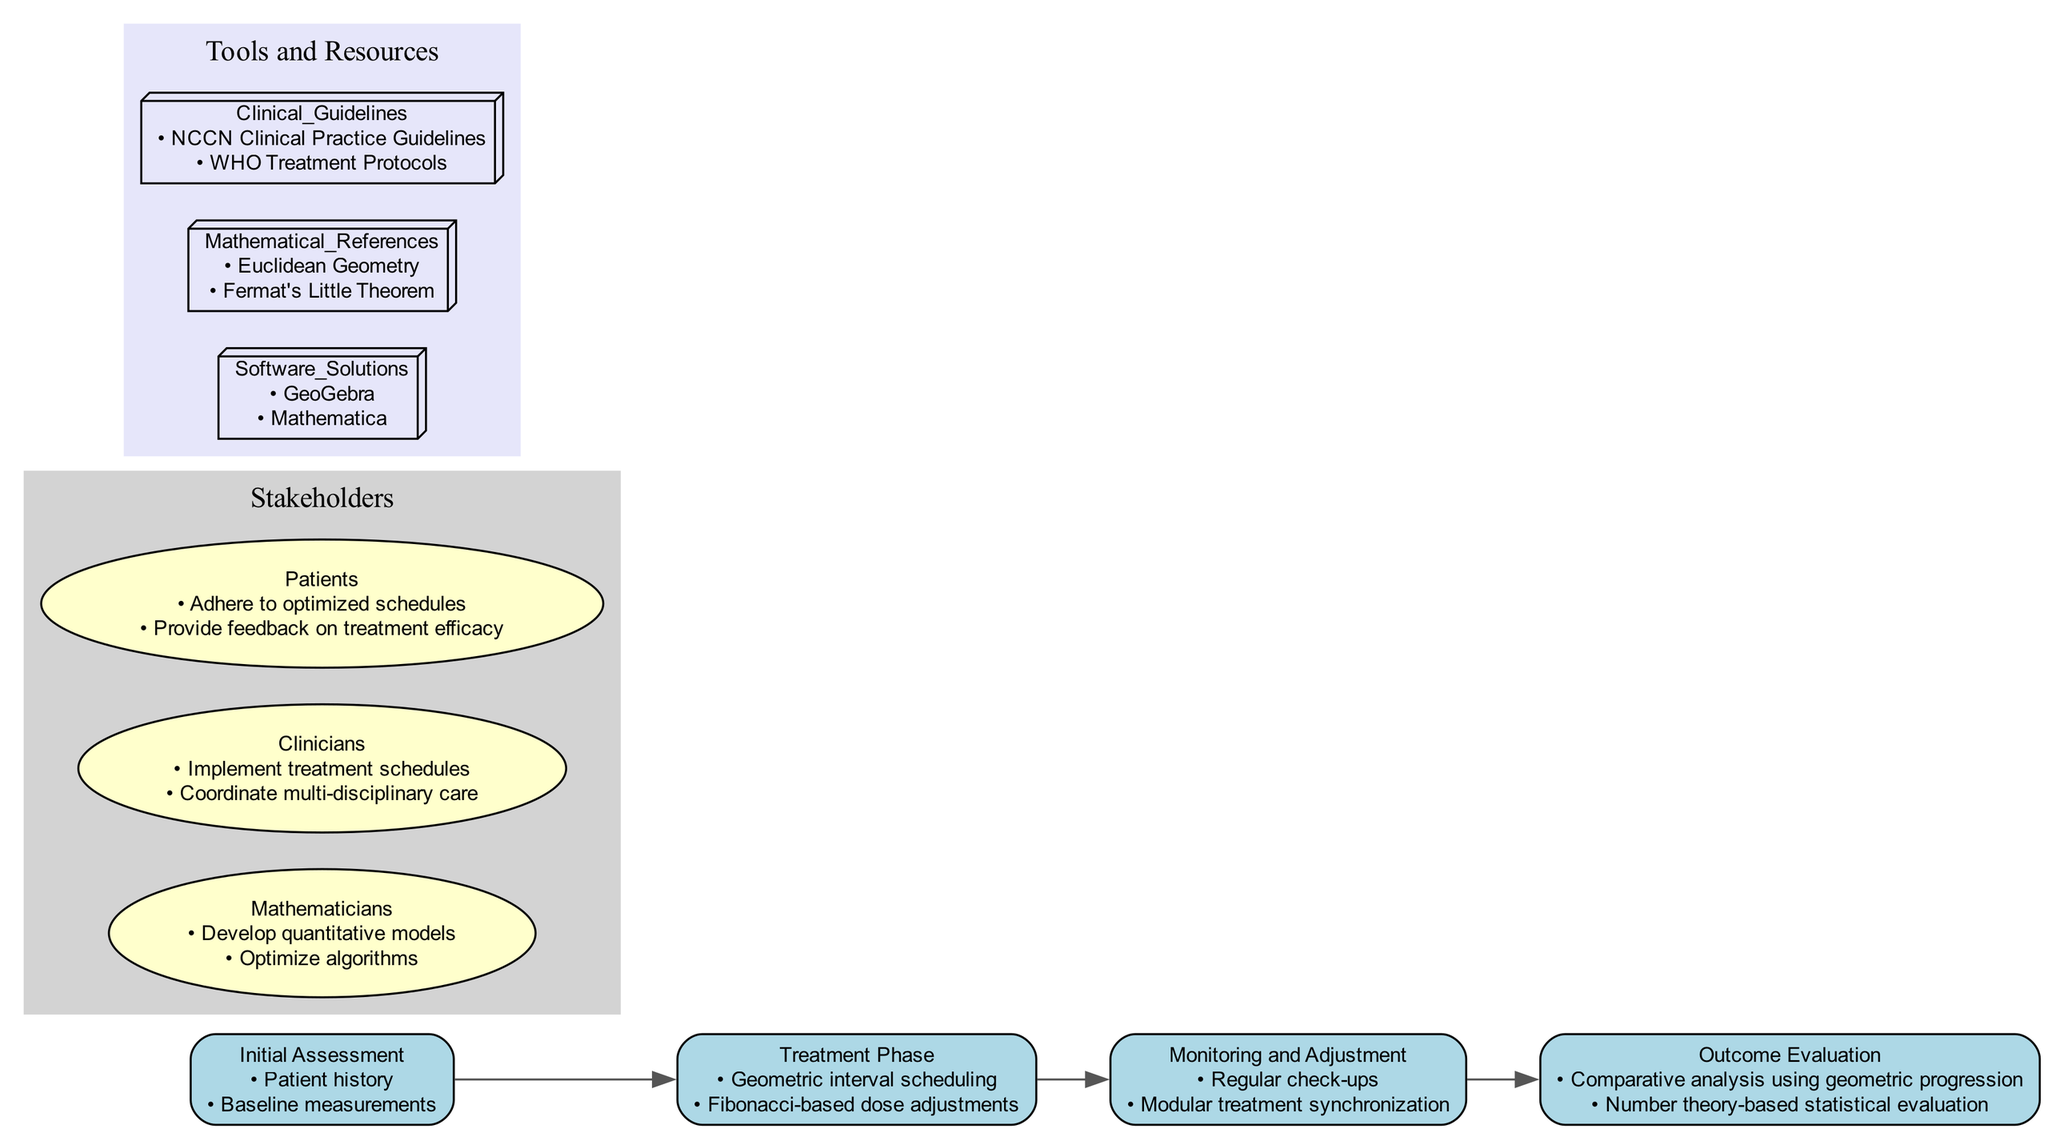What are the geometric shapes mentioned in the diagram? The diagram lists three geometric shapes under the "Geometry Principles" section: Ellipses, Parabolas, and Tessellations. These shapes are used in the context of optimizing treatment schedules.
Answer: Ellipses, Parabolas, Tessellations How many steps are in the Clinical Pathway? The Clinical Pathway consists of four distinct steps: Initial Assessment, Treatment Phase, Monitoring and Adjustment, and Outcome Evaluation. These steps represent the progression of a patient's treatment.
Answer: 4 Which mathematical reference is included in the Tools and Resources section? The Tools and Resources section lists two mathematical references, one of which is Euclidean Geometry. This reference pertains to the geometric aspects of the treatment optimization.
Answer: Euclidean Geometry What roles do clinicians play according to the diagram? Clinicians have two main roles listed in the Stakeholders section: Implement treatment schedules and Coordinate multi-disciplinary care. These roles emphasize their active participation in patient management.
Answer: Implement treatment schedules, Coordinate multi-disciplinary care What method is suggested for dose adjustments in the Treatment Phase? The Treatment Phase indicates that Fibonacci-based dose adjustments are a recommended method for customizing patient treatment schedules based on natural rhythms, integrating number theory into clinical practice.
Answer: Fibonacci-based dose adjustments How does the "Outcome Evaluation" step assess treatment effectiveness? The "Outcome Evaluation" step employs comparative analysis using geometric progression and number theory-based statistical evaluation. This dual approach ensures a thorough assessment of treatment results.
Answer: Comparative analysis using geometric progression, Number theory-based statistical evaluation Which software solutions are mentioned for resource optimization? The diagram specifically mentions two software solutions: GeoGebra and Mathematica. These tools assist in applying geometric and number-theoretical methods to optimize treatment schedules.
Answer: GeoGebra, Mathematica What is the role of patients in the Clinical Pathway? Patients have two specific roles: Adhere to optimized schedules and Provide feedback on treatment efficacy. Their participation is crucial for the successful implementation of treatment plans within this framework.
Answer: Adhere to optimized schedules, Provide feedback on treatment efficacy What is one objective of enhancing periodic treatment schedules with Primorial numbers? One objective of enhancing periodic treatment schedules with Primorial numbers is to prevent synchronization issues in modular therapies. This application shows how number theory can aid in clinical timing.
Answer: Preventing synchronization issues in modular therapies 